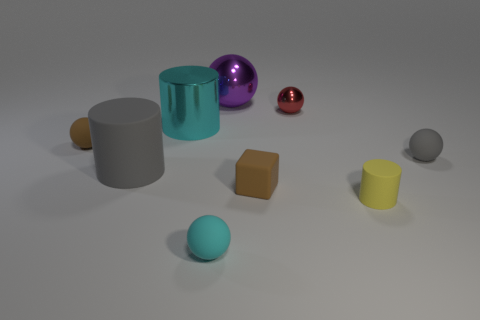Is the number of big gray matte objects that are to the right of the tiny red shiny thing greater than the number of tiny matte cylinders?
Make the answer very short. No. How many matte things are either large gray cylinders or tiny gray objects?
Your answer should be very brief. 2. There is a object that is behind the matte block and right of the red ball; how big is it?
Your response must be concise. Small. There is a small matte object that is on the right side of the small yellow thing; is there a gray matte ball that is right of it?
Your answer should be compact. No. How many small gray spheres are to the left of the brown matte sphere?
Your answer should be compact. 0. There is a tiny metallic thing that is the same shape as the small gray matte thing; what is its color?
Offer a very short reply. Red. Are the small brown object that is on the right side of the purple shiny thing and the big object in front of the big metallic cylinder made of the same material?
Your response must be concise. Yes. There is a small matte cylinder; does it have the same color as the big cylinder that is to the right of the gray cylinder?
Ensure brevity in your answer.  No. There is a tiny object that is in front of the small brown block and to the right of the purple shiny sphere; what shape is it?
Your answer should be very brief. Cylinder. How many brown shiny things are there?
Your response must be concise. 0. 